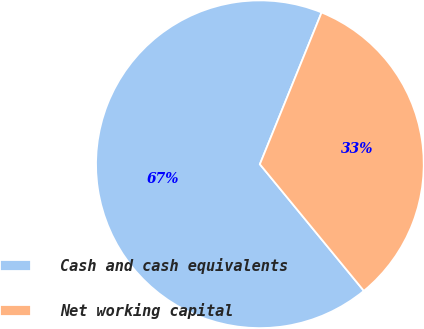<chart> <loc_0><loc_0><loc_500><loc_500><pie_chart><fcel>Cash and cash equivalents<fcel>Net working capital<nl><fcel>67.09%<fcel>32.91%<nl></chart> 